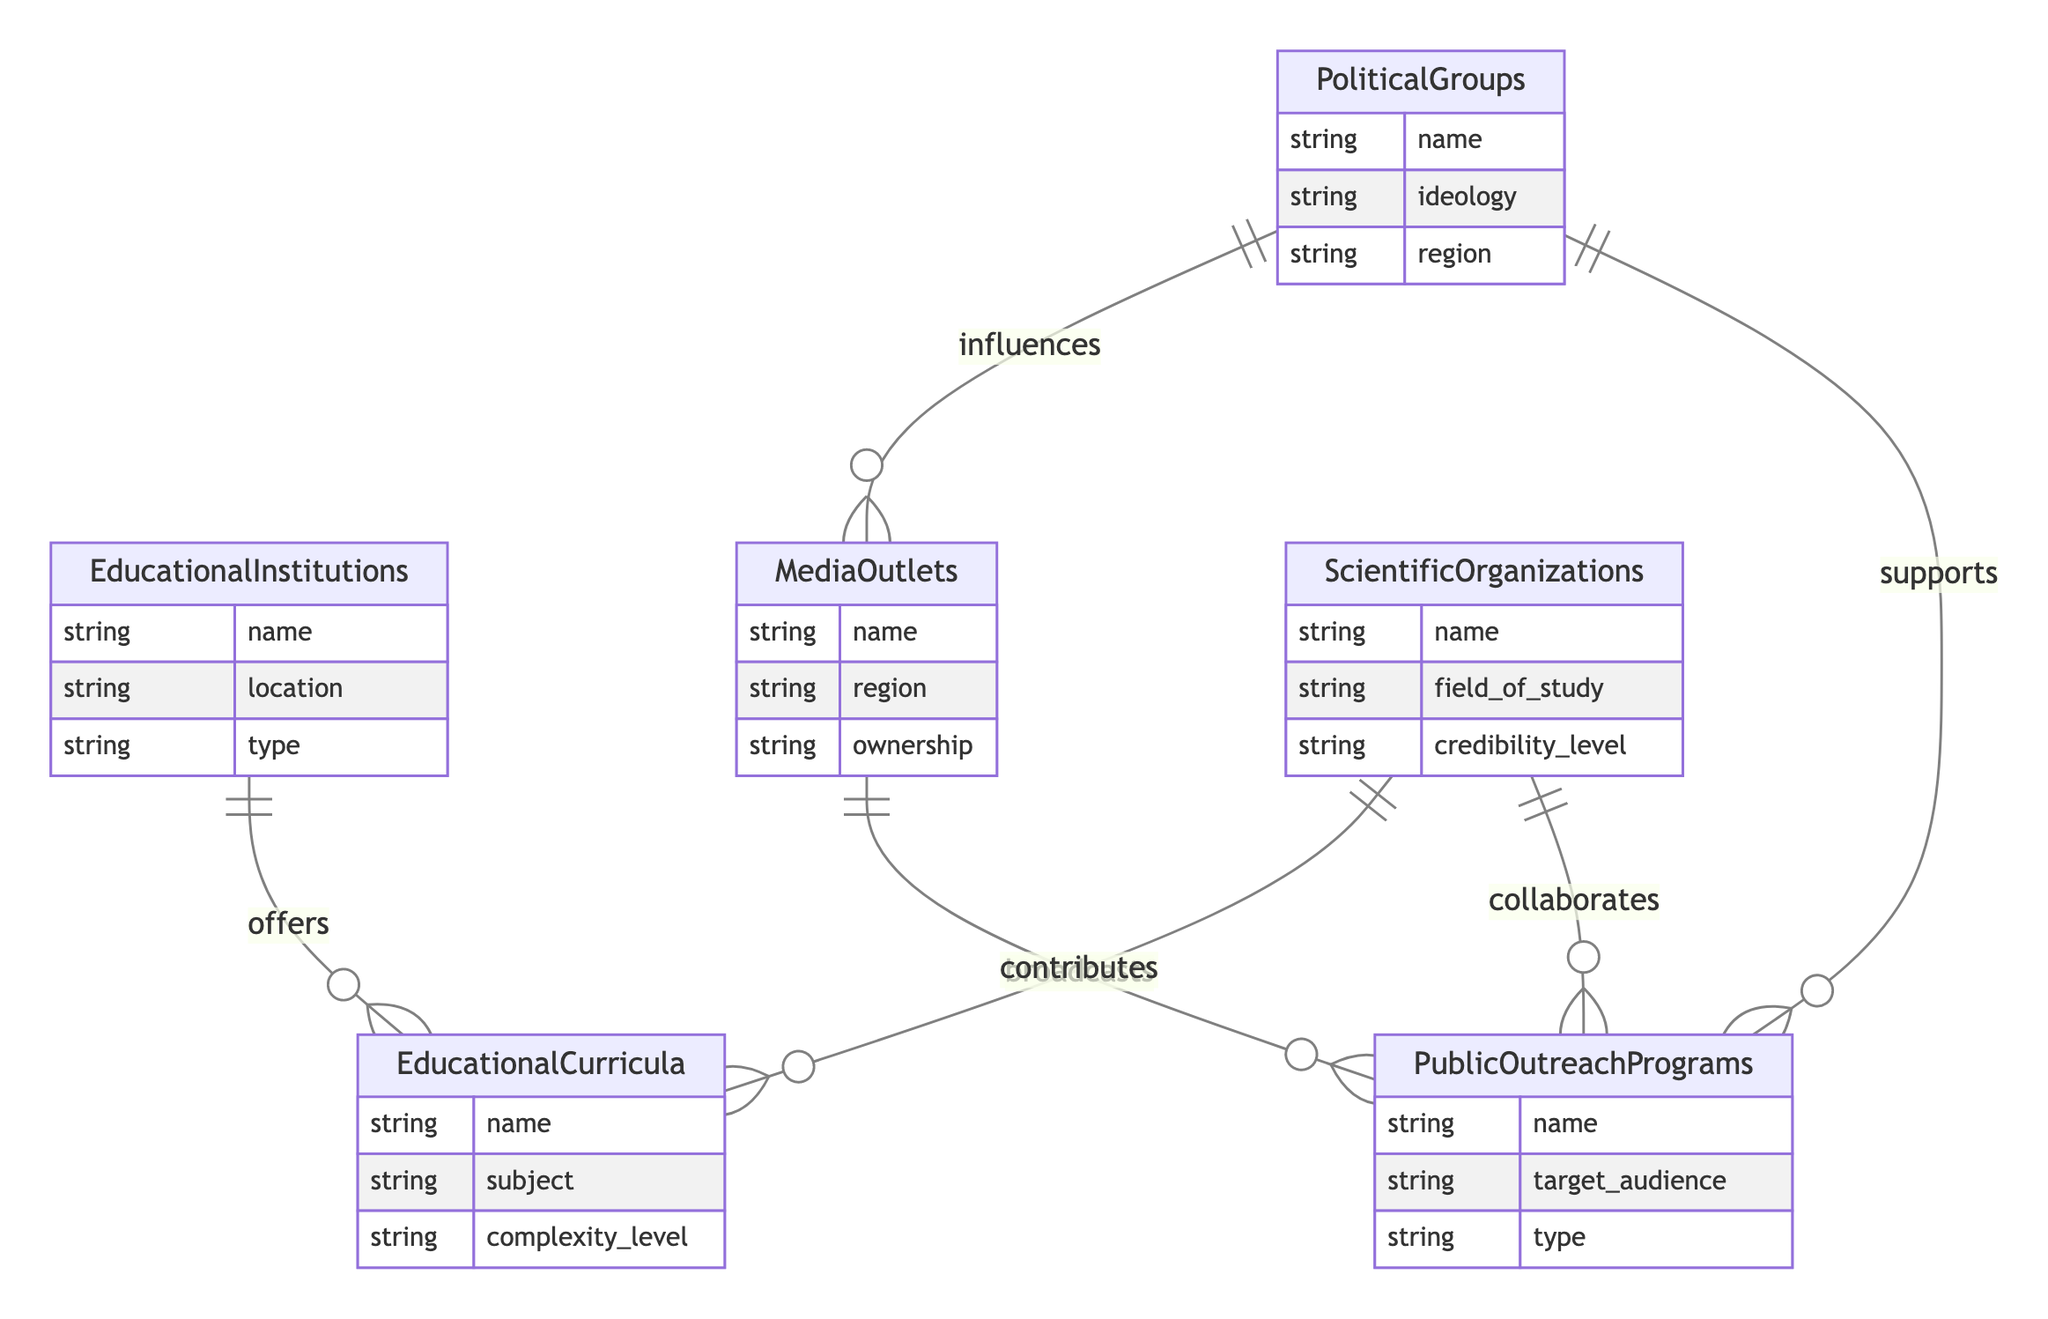What entities are connected to Educational Institutions? The diagram shows that the Educational Institutions are connected to Educational Curricula through the relationship "offers."
Answer: Educational Curricula How many relationships does Scientific Organizations have? Scientific Organizations are connected to two entities: Educational Curricula (contributes) and Public Outreach Programs (collaborates), so they have two relationships.
Answer: 2 What is the relationship between Political Groups and Media Outlets? The relationship between Political Groups and Media Outlets is "influences," indicating Political Groups impact the Media Outlets.
Answer: influences Which entity directly collaborates with Public Outreach Programs? The diagram indicates that Scientific Organizations collaborate with Public Outreach Programs, thus they are directly linked.
Answer: Scientific Organizations What attributes does the Media Outlets entity have? The Media Outlets entity has three attributes: name, region, and ownership which provide details about the Media Outlets.
Answer: name, region, ownership Which entities are involved in broadcasting Public Outreach Programs? The diagram specifies that Media Outlets are responsible for broadcasting Public Outreach Programs, establishing a direct link.
Answer: Media Outlets What type of programs do Political Groups support? Political Groups support Public Outreach Programs through funding and events, demonstrating their backing of these initiatives.
Answer: Public Outreach Programs How many entities are linked to Political Groups? Political Groups are linked to two entities: Media Outlets (influences) and Public Outreach Programs (supports), resulting in two connections.
Answer: 2 What role does Scientific Organizations play in Educational Curricula? Scientific Organizations contribute to Educational Curricula by providing research papers and recommended reading.
Answer: contributes 